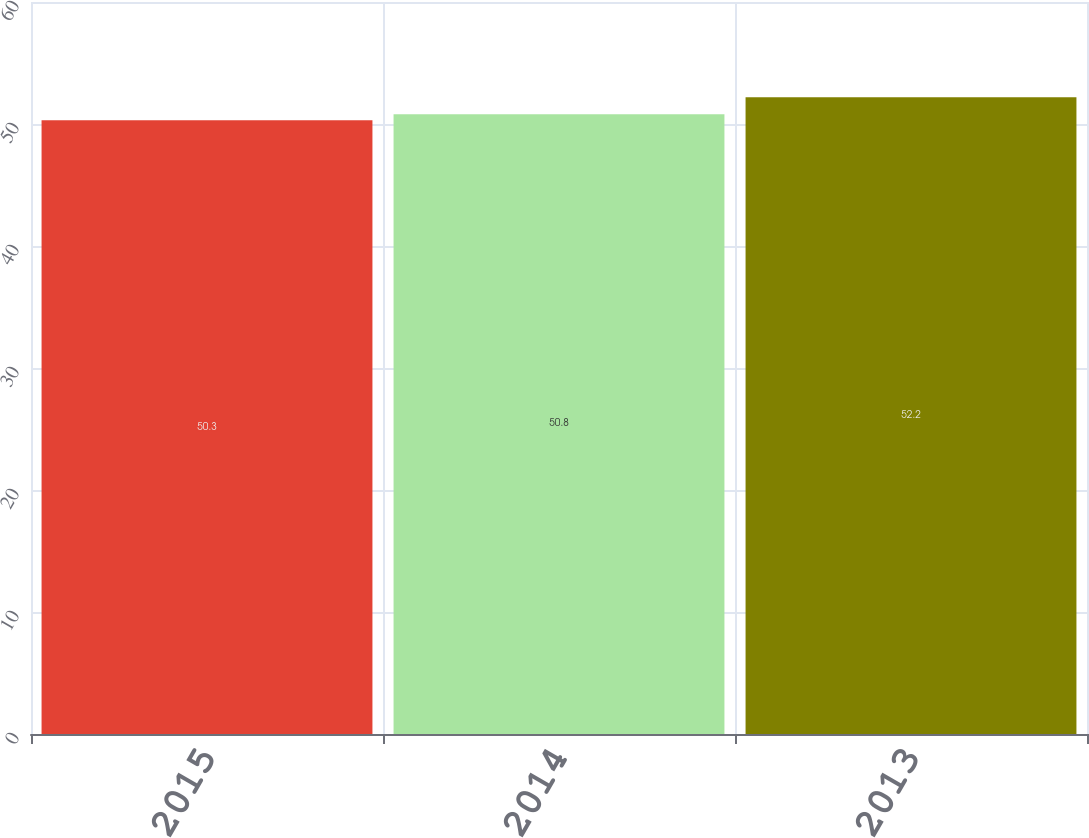<chart> <loc_0><loc_0><loc_500><loc_500><bar_chart><fcel>2015<fcel>2014<fcel>2013<nl><fcel>50.3<fcel>50.8<fcel>52.2<nl></chart> 